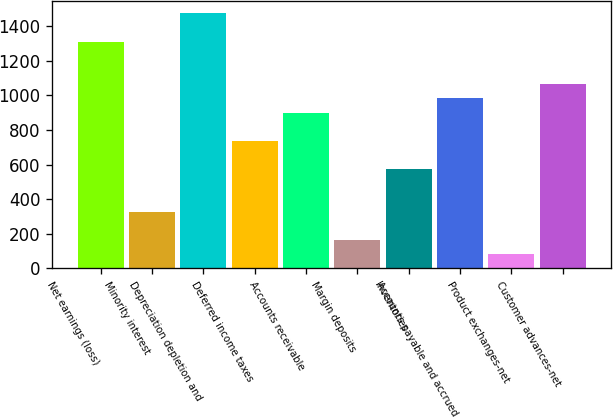<chart> <loc_0><loc_0><loc_500><loc_500><bar_chart><fcel>Net earnings (loss)<fcel>Minority interest<fcel>Depreciation depletion and<fcel>Deferred income taxes<fcel>Accounts receivable<fcel>Margin deposits<fcel>Inventories<fcel>Accounts payable and accrued<fcel>Product exchanges-net<fcel>Customer advances-net<nl><fcel>1309.6<fcel>328<fcel>1473.2<fcel>737<fcel>900.6<fcel>164.4<fcel>573.4<fcel>982.4<fcel>82.6<fcel>1064.2<nl></chart> 